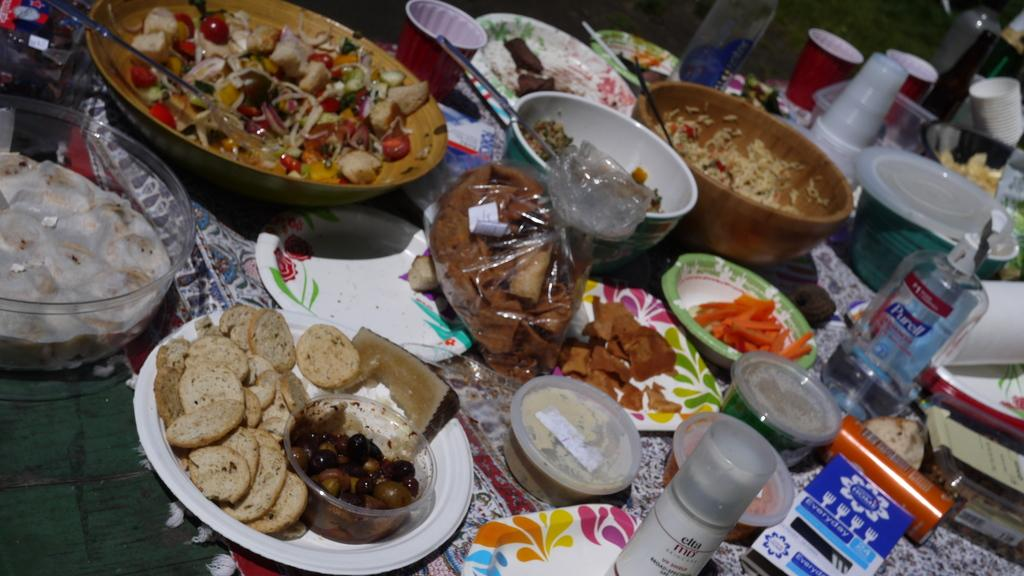What types of dishes are present in the image? There are plates, bowls, and glasses in the image. What else can be found on the table in the image? There are bottles and covers on the table in the image. What is the primary purpose of the objects on the table? The objects on the table are used for serving and consuming food and beverages. Is there any food visible in the image? Yes, there is food in the image. What type of humor can be seen in the image? There is no humor present in the image; it is a still life of dishes and food. Can you see any branches in the image? There are no branches visible in the image. 